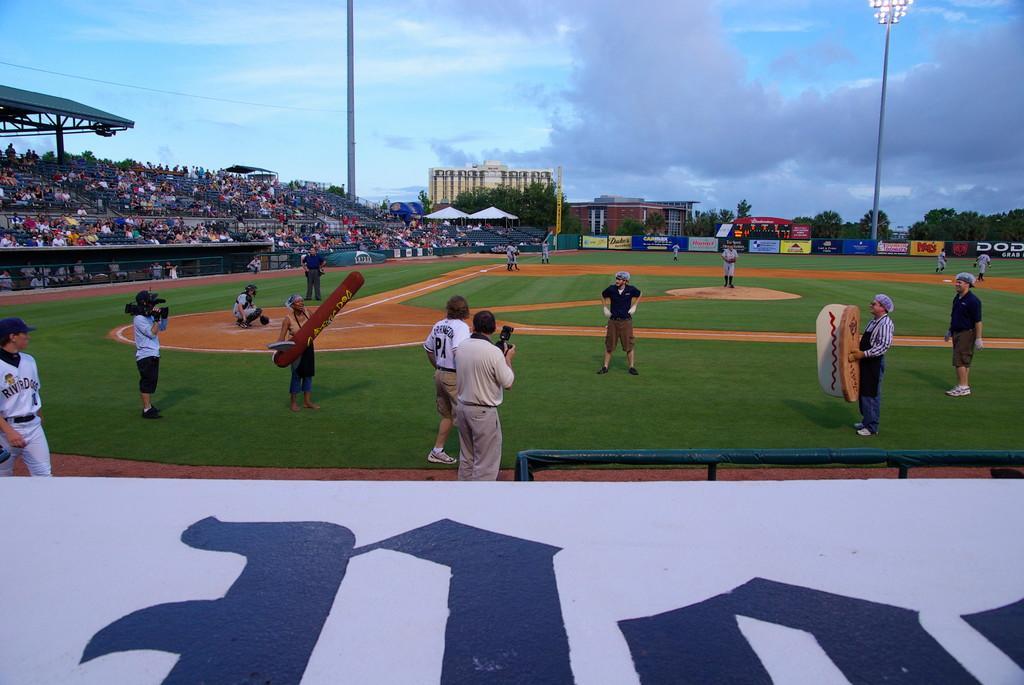Can you describe this image briefly? This is a playing ground. Here I can see few people are standing on the ground. Two people are holding the cameras in the hands. At the bottom there is a white color board on which I can see some text. On the right side there is a metal rod. In the background there are many trees and buildings. On the left side many people are sitting on the chairs facing towards the ground. At the top of the image I can see the sky. 